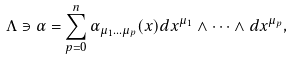Convert formula to latex. <formula><loc_0><loc_0><loc_500><loc_500>\Lambda \ni \alpha = \sum ^ { n } _ { p = 0 } \alpha _ { \mu _ { 1 } \dots \mu _ { p } } ( x ) d x ^ { \mu _ { 1 } } \wedge \dots \wedge d x ^ { \mu _ { p } } ,</formula> 